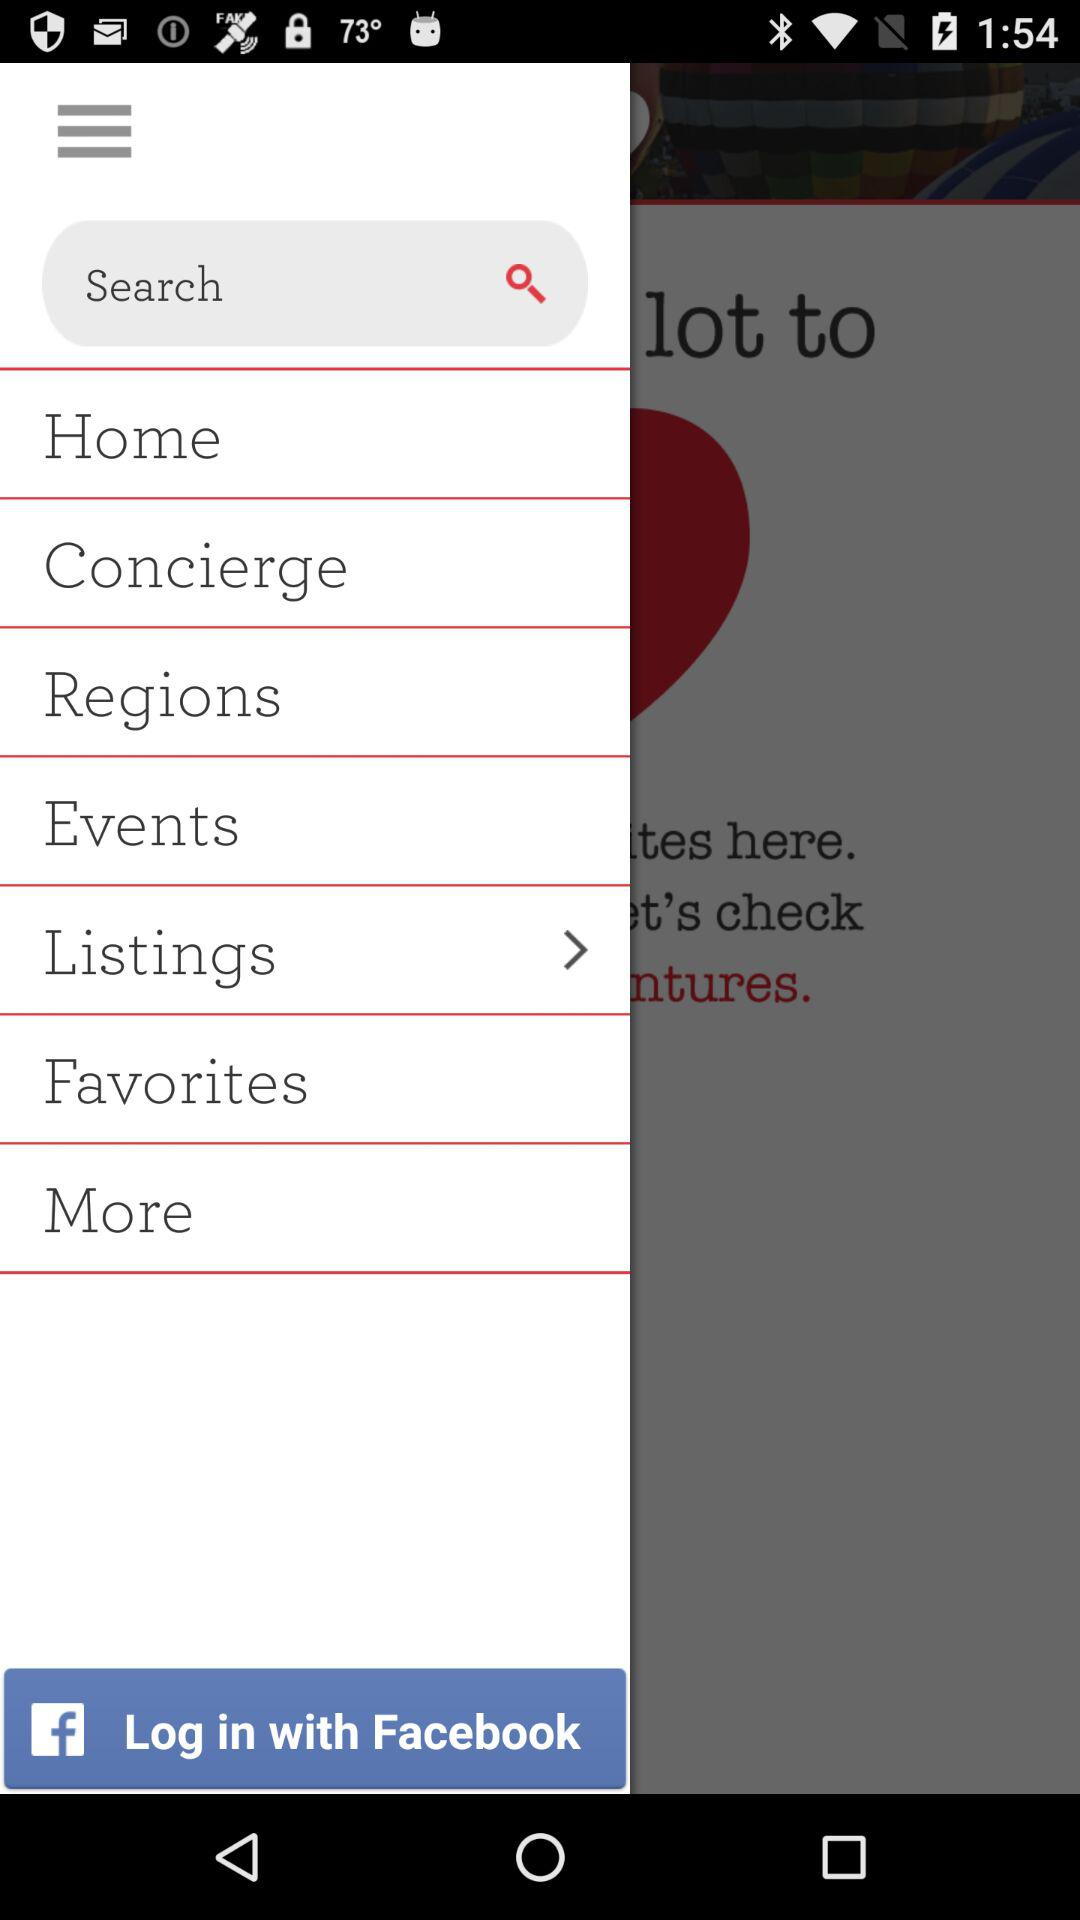Through what account can logging in be done? Logging in can be done through "Facebook". 